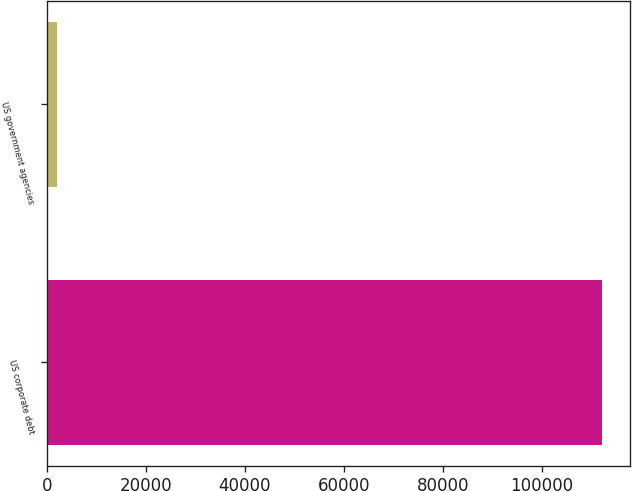Convert chart to OTSL. <chart><loc_0><loc_0><loc_500><loc_500><bar_chart><fcel>US corporate debt<fcel>US government agencies<nl><fcel>112117<fcel>1998<nl></chart> 